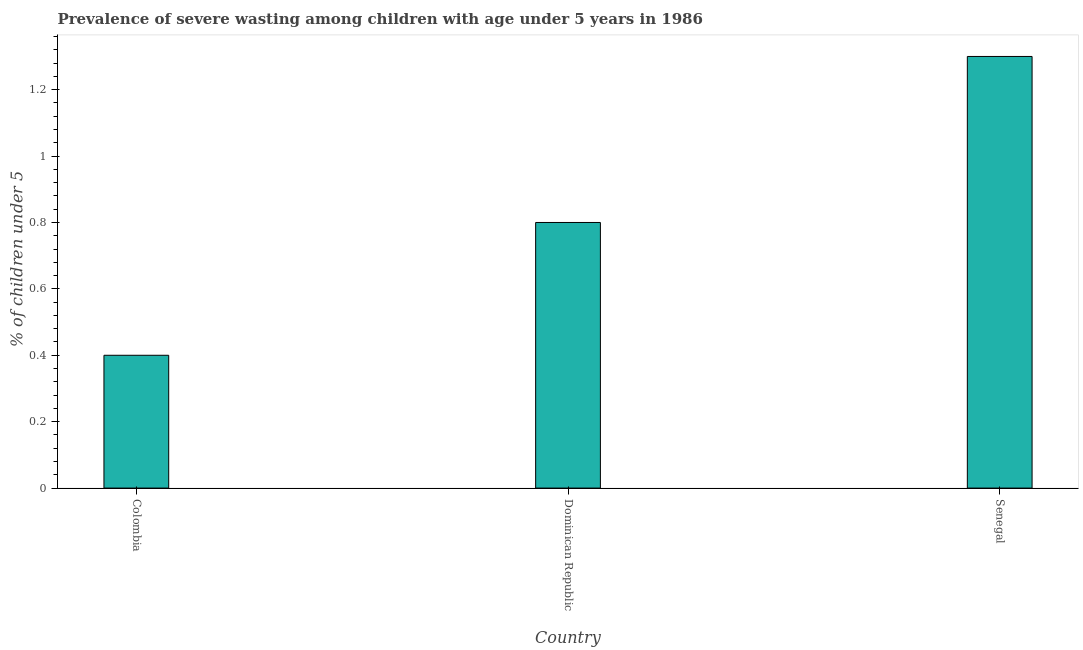Does the graph contain grids?
Offer a very short reply. No. What is the title of the graph?
Give a very brief answer. Prevalence of severe wasting among children with age under 5 years in 1986. What is the label or title of the Y-axis?
Offer a very short reply.  % of children under 5. What is the prevalence of severe wasting in Senegal?
Offer a terse response. 1.3. Across all countries, what is the maximum prevalence of severe wasting?
Provide a succinct answer. 1.3. Across all countries, what is the minimum prevalence of severe wasting?
Keep it short and to the point. 0.4. In which country was the prevalence of severe wasting maximum?
Ensure brevity in your answer.  Senegal. In which country was the prevalence of severe wasting minimum?
Ensure brevity in your answer.  Colombia. What is the sum of the prevalence of severe wasting?
Your answer should be very brief. 2.5. What is the difference between the prevalence of severe wasting in Colombia and Senegal?
Provide a succinct answer. -0.9. What is the average prevalence of severe wasting per country?
Give a very brief answer. 0.83. What is the median prevalence of severe wasting?
Offer a terse response. 0.8. What is the ratio of the prevalence of severe wasting in Dominican Republic to that in Senegal?
Keep it short and to the point. 0.61. Is the difference between the prevalence of severe wasting in Colombia and Dominican Republic greater than the difference between any two countries?
Provide a succinct answer. No. What is the difference between the highest and the second highest prevalence of severe wasting?
Give a very brief answer. 0.5. How many countries are there in the graph?
Make the answer very short. 3. What is the difference between two consecutive major ticks on the Y-axis?
Offer a terse response. 0.2. Are the values on the major ticks of Y-axis written in scientific E-notation?
Provide a succinct answer. No. What is the  % of children under 5 in Colombia?
Your answer should be compact. 0.4. What is the  % of children under 5 of Dominican Republic?
Make the answer very short. 0.8. What is the  % of children under 5 of Senegal?
Provide a succinct answer. 1.3. What is the difference between the  % of children under 5 in Colombia and Dominican Republic?
Provide a short and direct response. -0.4. What is the ratio of the  % of children under 5 in Colombia to that in Dominican Republic?
Provide a short and direct response. 0.5. What is the ratio of the  % of children under 5 in Colombia to that in Senegal?
Keep it short and to the point. 0.31. What is the ratio of the  % of children under 5 in Dominican Republic to that in Senegal?
Ensure brevity in your answer.  0.61. 